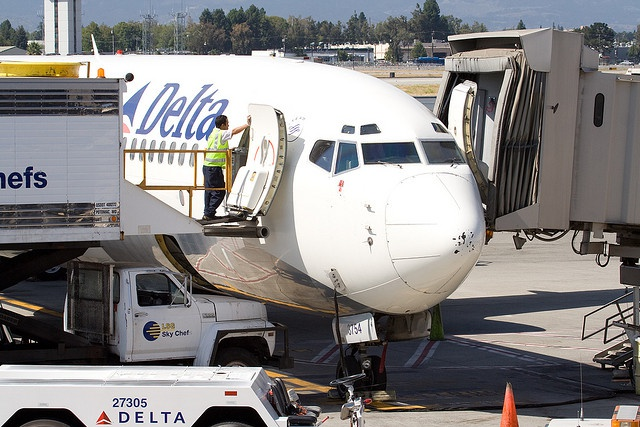Describe the objects in this image and their specific colors. I can see airplane in darkgray, white, gray, and black tones, truck in darkgray, black, and gray tones, truck in darkgray, lightgray, black, and gray tones, truck in darkgray, black, and gray tones, and people in darkgray, black, beige, khaki, and gray tones in this image. 